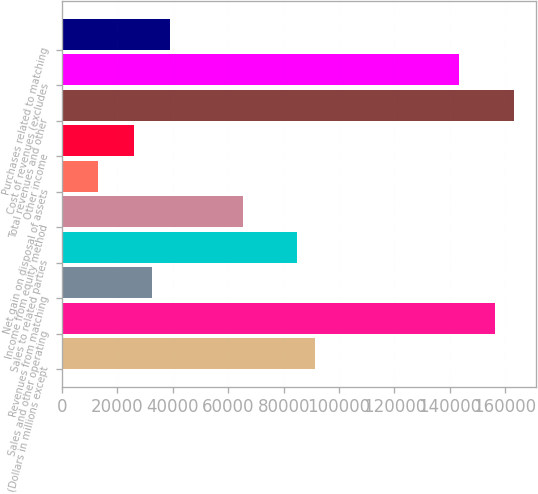Convert chart. <chart><loc_0><loc_0><loc_500><loc_500><bar_chart><fcel>(Dollars in millions except<fcel>Sales and other operating<fcel>Revenues from matching<fcel>Sales to related parties<fcel>Income from equity method<fcel>Net gain on disposal of assets<fcel>Other income<fcel>Total revenues and other<fcel>Cost of revenues (excludes<fcel>Purchases related to matching<nl><fcel>91288.6<fcel>156493<fcel>32605<fcel>84768.2<fcel>65207<fcel>13043.8<fcel>26084.6<fcel>163013<fcel>143452<fcel>39125.4<nl></chart> 